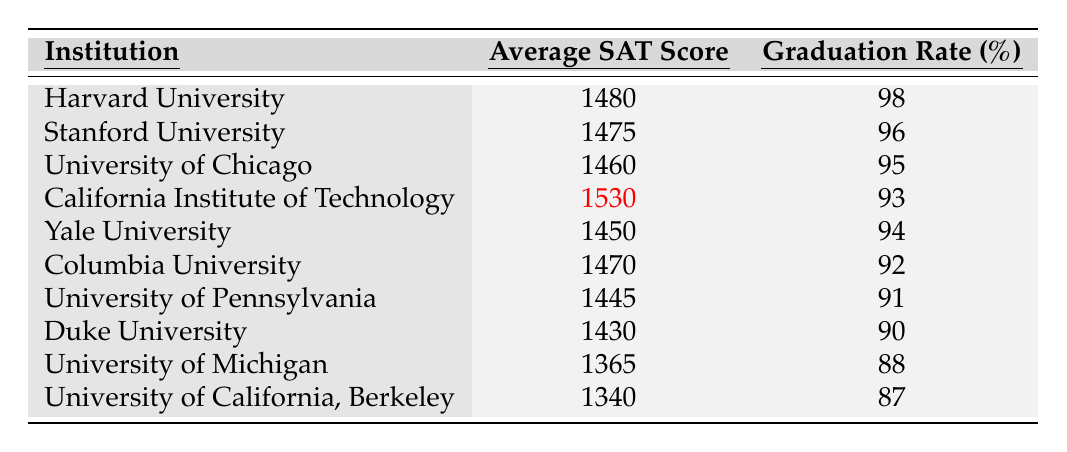What is the graduation rate for Harvard University? The graduation rate for Harvard University is listed directly in the table under the graduation rate column, which shows a value of 98%.
Answer: 98% Which institution has the highest average SAT score? The average SAT scores are compared in the second column of the table. California Institute of Technology has the highest SAT score of 1530.
Answer: California Institute of Technology What is the difference in graduation rates between Yale University and Duke University? Yale University's graduation rate is 94% and Duke University's is 90%. The difference is calculated by subtracting Duke's rate from Yale's: 94% - 90% = 4%.
Answer: 4% Is the average SAT score of the University of California, Berkeley greater than 1350? The average SAT score for the University of California, Berkeley is 1340, which is less than 1350. Therefore, the statement is false.
Answer: No What is the average graduation rate for the institutions listed in the table? To find the average graduation rate, sum all the graduation rates: (98 + 96 + 95 + 93 + 94 + 92 + 91 + 90 + 88 + 87) = 924. There are 10 institutions, so the average is 924/10 = 92.4%.
Answer: 92.4% Which institution has a graduation rate of 88%? By looking at the graduation rate column in the table, it is clear that the University of Michigan has a graduation rate of 88%.
Answer: University of Michigan If we consider the institutions listed, what percentage of them have a graduation rate above 90%? There are a total of 10 institutions. The ones with graduation rates above 90% are Harvard, Stanford, University of Chicago, California Institute of Technology, and Yale, which totals 5 institutions. Therefore, the percentage is (5/10) × 100% = 50%.
Answer: 50% What is the average SAT score of the institutions with graduation rates above 90%? The institutions with graduation rates above 90% are Harvard (1480), Stanford (1475), University of Chicago (1460), California Institute of Technology (1530), and Yale (1450). Summing these scores gives 7400. The average is 7400/5 = 1480.
Answer: 1480 Which institution has the lowest average SAT score, and what is that score? By checking the average SAT scores listed in the table, University of California, Berkeley has the lowest average SAT score of 1340.
Answer: University of California, Berkeley, 1340 Does the institution with the highest SAT score have the highest graduation rate? The highest SAT score is for California Institute of Technology at 1530, with a graduation rate of 93%. The highest graduation rate belongs to Harvard University at 98%. Hence, the answer is no.
Answer: No 